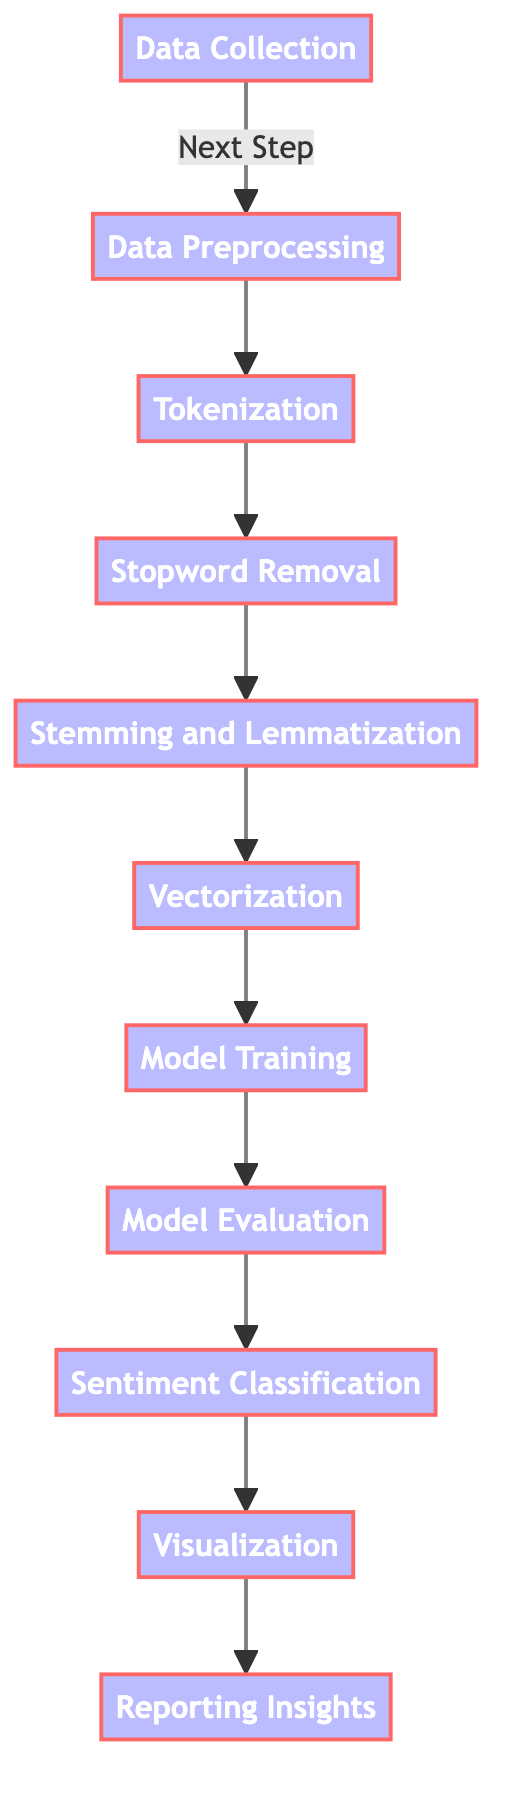What is the first step in the diagram? The diagram starts with the 'Data Collection' node, which is the first step in the process of sentiment analysis.
Answer: Data Collection How many steps are involved in the process from data collection to reporting insights? Counting the nodes from 'Data Collection' to 'Reporting Insights', there are a total of 11 steps in this flowchart.
Answer: 11 What follows after 'Model Evaluation'? Following 'Model Evaluation', the next step in the diagram is 'Sentiment Classification'.
Answer: Sentiment Classification Which step comes before 'Vectorization'? Before 'Vectorization', the step listed in the diagram is 'Stemming and Lemmatization'.
Answer: Stemming and Lemmatization What step directly precedes 'Reporting Insights'? The step that comes right before 'Reporting Insights' is 'Visualization'.
Answer: Visualization Which two steps are linked directly to 'Model Training'? The steps linked directly to 'Model Training' are 'Vectorization' and 'Model Evaluation', as they are part of the process flow leading to model training.
Answer: Vectorization and Model Evaluation How many nodes are focused on data preprocessing? There are four nodes focused on data preprocessing in the diagram: 'Data Preprocessing', 'Tokenization', 'Stopword Removal', and 'Stemming and Lemmatization'.
Answer: 4 What process follows 'Data Preprocessing'? The process that follows 'Data Preprocessing' is 'Tokenization', which is the next step in the flow.
Answer: Tokenization What is the final output type indicated in the diagram? The final output type indicated in the diagram is 'Reporting Insights', which represents the last step in this workflow.
Answer: Reporting Insights 